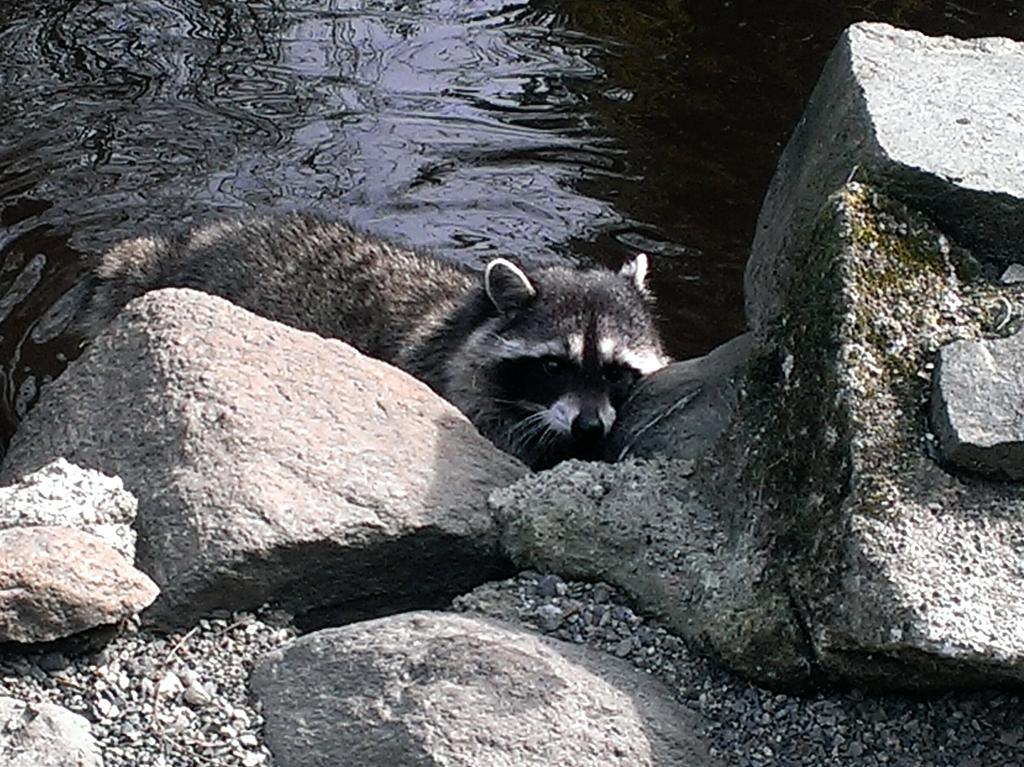What type of animal is present in the image? There is an animal in the image, but its specific type cannot be determined from the provided facts. What other objects or elements can be seen in the image? There are rocks and water visible in the image. What type of cakes can be seen being prepared in the image? There is no reference to cakes or any baking activity in the image. How does the animal interact with the dirt in the image? There is no dirt present in the image, and therefore no such interaction can be observed. 